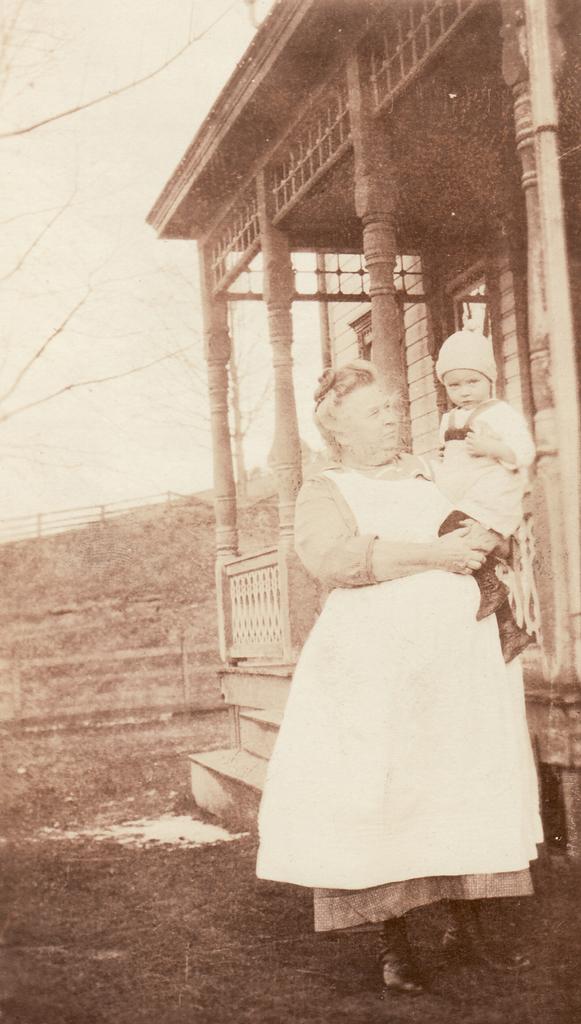Could you give a brief overview of what you see in this image? In this picture we can see a woman standing on the ground and carrying a child and in the background we can see a building, trees, sky. 